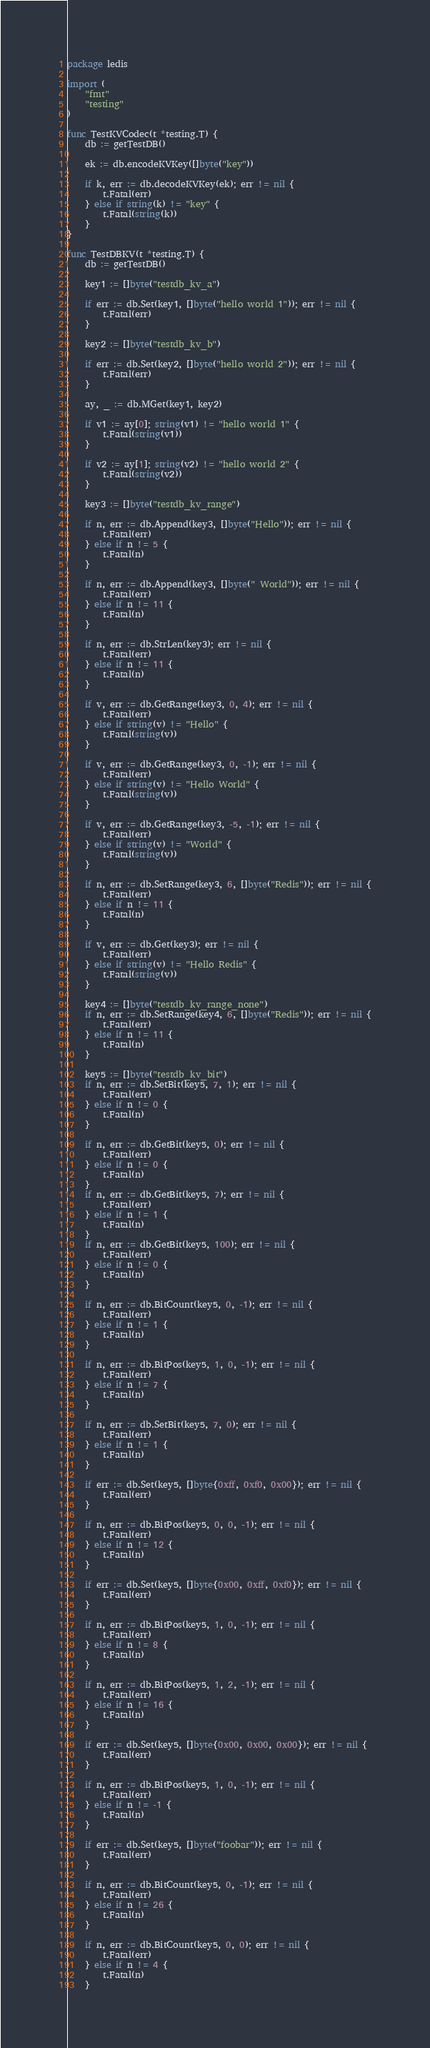<code> <loc_0><loc_0><loc_500><loc_500><_Go_>package ledis

import (
	"fmt"
	"testing"
)

func TestKVCodec(t *testing.T) {
	db := getTestDB()

	ek := db.encodeKVKey([]byte("key"))

	if k, err := db.decodeKVKey(ek); err != nil {
		t.Fatal(err)
	} else if string(k) != "key" {
		t.Fatal(string(k))
	}
}

func TestDBKV(t *testing.T) {
	db := getTestDB()

	key1 := []byte("testdb_kv_a")

	if err := db.Set(key1, []byte("hello world 1")); err != nil {
		t.Fatal(err)
	}

	key2 := []byte("testdb_kv_b")

	if err := db.Set(key2, []byte("hello world 2")); err != nil {
		t.Fatal(err)
	}

	ay, _ := db.MGet(key1, key2)

	if v1 := ay[0]; string(v1) != "hello world 1" {
		t.Fatal(string(v1))
	}

	if v2 := ay[1]; string(v2) != "hello world 2" {
		t.Fatal(string(v2))
	}

	key3 := []byte("testdb_kv_range")

	if n, err := db.Append(key3, []byte("Hello")); err != nil {
		t.Fatal(err)
	} else if n != 5 {
		t.Fatal(n)
	}

	if n, err := db.Append(key3, []byte(" World")); err != nil {
		t.Fatal(err)
	} else if n != 11 {
		t.Fatal(n)
	}

	if n, err := db.StrLen(key3); err != nil {
		t.Fatal(err)
	} else if n != 11 {
		t.Fatal(n)
	}

	if v, err := db.GetRange(key3, 0, 4); err != nil {
		t.Fatal(err)
	} else if string(v) != "Hello" {
		t.Fatal(string(v))
	}

	if v, err := db.GetRange(key3, 0, -1); err != nil {
		t.Fatal(err)
	} else if string(v) != "Hello World" {
		t.Fatal(string(v))
	}

	if v, err := db.GetRange(key3, -5, -1); err != nil {
		t.Fatal(err)
	} else if string(v) != "World" {
		t.Fatal(string(v))
	}

	if n, err := db.SetRange(key3, 6, []byte("Redis")); err != nil {
		t.Fatal(err)
	} else if n != 11 {
		t.Fatal(n)
	}

	if v, err := db.Get(key3); err != nil {
		t.Fatal(err)
	} else if string(v) != "Hello Redis" {
		t.Fatal(string(v))
	}

	key4 := []byte("testdb_kv_range_none")
	if n, err := db.SetRange(key4, 6, []byte("Redis")); err != nil {
		t.Fatal(err)
	} else if n != 11 {
		t.Fatal(n)
	}

	key5 := []byte("testdb_kv_bit")
	if n, err := db.SetBit(key5, 7, 1); err != nil {
		t.Fatal(err)
	} else if n != 0 {
		t.Fatal(n)
	}

	if n, err := db.GetBit(key5, 0); err != nil {
		t.Fatal(err)
	} else if n != 0 {
		t.Fatal(n)
	}
	if n, err := db.GetBit(key5, 7); err != nil {
		t.Fatal(err)
	} else if n != 1 {
		t.Fatal(n)
	}
	if n, err := db.GetBit(key5, 100); err != nil {
		t.Fatal(err)
	} else if n != 0 {
		t.Fatal(n)
	}

	if n, err := db.BitCount(key5, 0, -1); err != nil {
		t.Fatal(err)
	} else if n != 1 {
		t.Fatal(n)
	}

	if n, err := db.BitPos(key5, 1, 0, -1); err != nil {
		t.Fatal(err)
	} else if n != 7 {
		t.Fatal(n)
	}

	if n, err := db.SetBit(key5, 7, 0); err != nil {
		t.Fatal(err)
	} else if n != 1 {
		t.Fatal(n)
	}

	if err := db.Set(key5, []byte{0xff, 0xf0, 0x00}); err != nil {
		t.Fatal(err)
	}

	if n, err := db.BitPos(key5, 0, 0, -1); err != nil {
		t.Fatal(err)
	} else if n != 12 {
		t.Fatal(n)
	}

	if err := db.Set(key5, []byte{0x00, 0xff, 0xf0}); err != nil {
		t.Fatal(err)
	}

	if n, err := db.BitPos(key5, 1, 0, -1); err != nil {
		t.Fatal(err)
	} else if n != 8 {
		t.Fatal(n)
	}

	if n, err := db.BitPos(key5, 1, 2, -1); err != nil {
		t.Fatal(err)
	} else if n != 16 {
		t.Fatal(n)
	}

	if err := db.Set(key5, []byte{0x00, 0x00, 0x00}); err != nil {
		t.Fatal(err)
	}

	if n, err := db.BitPos(key5, 1, 0, -1); err != nil {
		t.Fatal(err)
	} else if n != -1 {
		t.Fatal(n)
	}

	if err := db.Set(key5, []byte("foobar")); err != nil {
		t.Fatal(err)
	}

	if n, err := db.BitCount(key5, 0, -1); err != nil {
		t.Fatal(err)
	} else if n != 26 {
		t.Fatal(n)
	}

	if n, err := db.BitCount(key5, 0, 0); err != nil {
		t.Fatal(err)
	} else if n != 4 {
		t.Fatal(n)
	}
</code> 